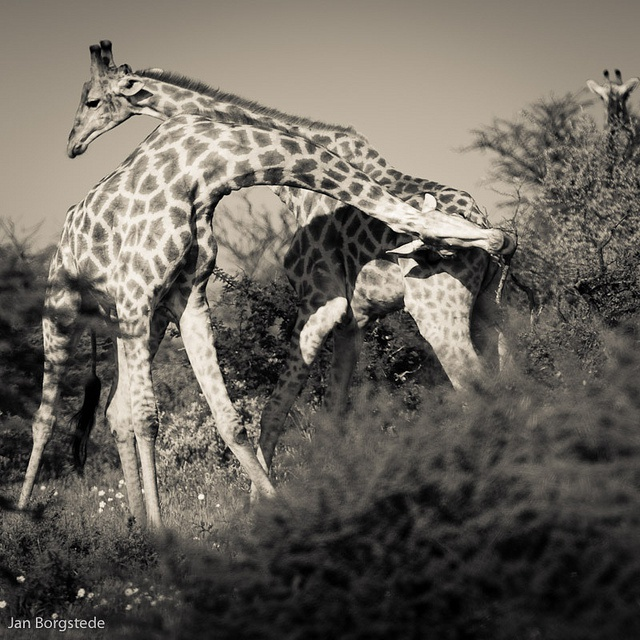Describe the objects in this image and their specific colors. I can see giraffe in gray, lightgray, darkgray, and black tones and giraffe in gray, black, darkgray, and lightgray tones in this image. 